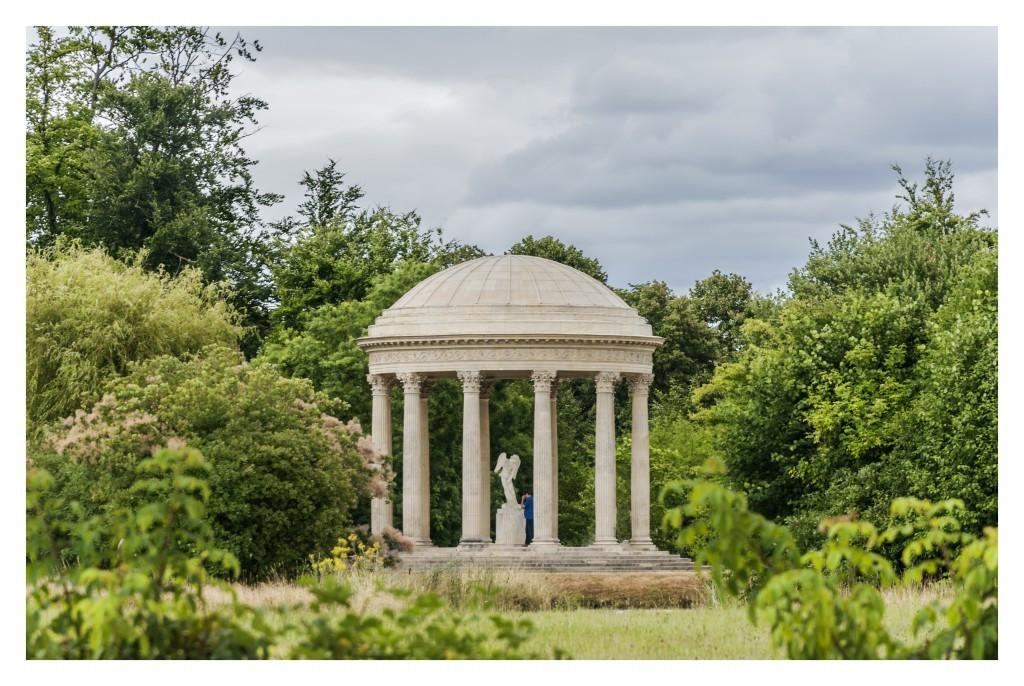What is located in the foreground of the image? There is a shelter in the foreground of the image. What can be found under the shelter? There is a sculpture under the shelter. Who is near the sculpture? There is a man standing near the sculpture. What type of vegetation is around the shelter? Trees are present around the shelter, and grass is visible around the shelter. What is visible at the top of the image? The sky is visible at the top of the image. How does the wind affect the hot air balloon in the image? There is no hot air balloon present in the image; it only features a shelter, a sculpture, a man, trees, grass, and the sky. 